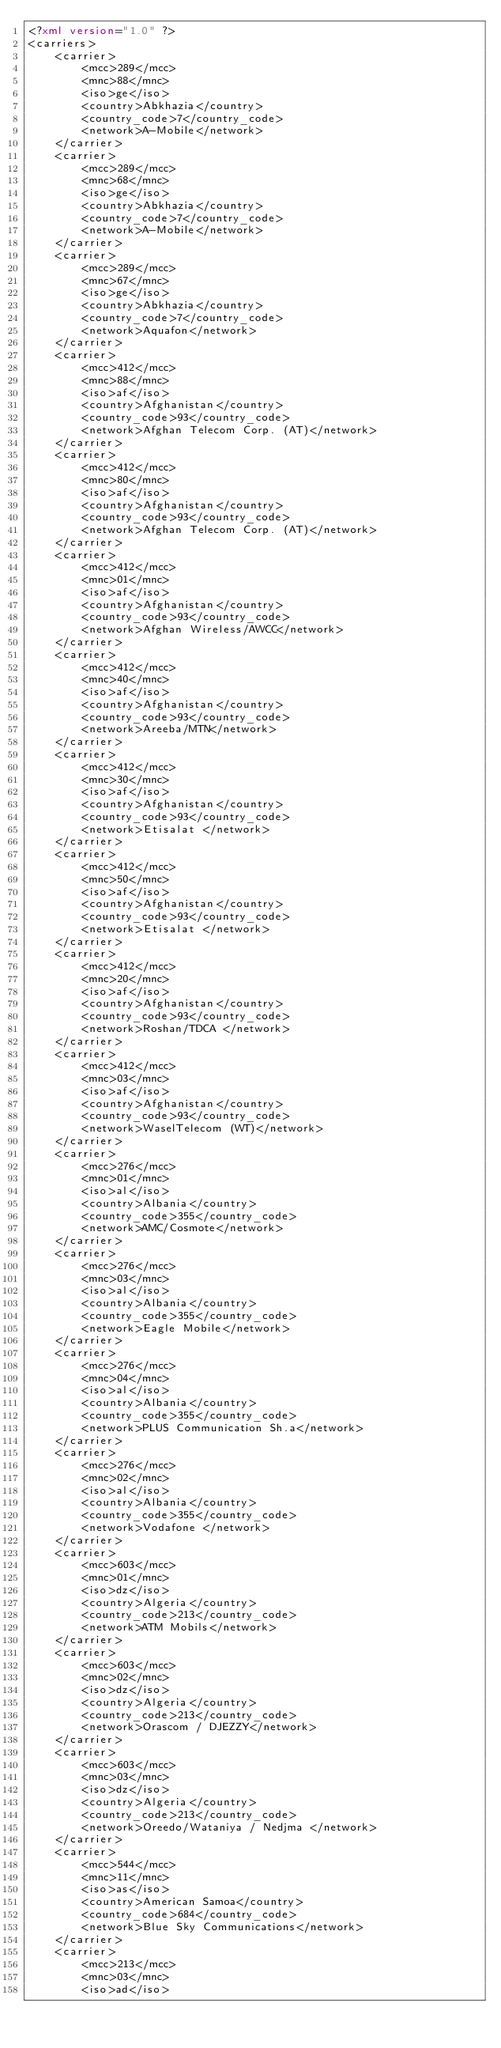Convert code to text. <code><loc_0><loc_0><loc_500><loc_500><_XML_><?xml version="1.0" ?>
<carriers>
    <carrier>
        <mcc>289</mcc>
        <mnc>88</mnc>
        <iso>ge</iso>
        <country>Abkhazia</country>
        <country_code>7</country_code>
        <network>A-Mobile</network>
    </carrier>
    <carrier>
        <mcc>289</mcc>
        <mnc>68</mnc>
        <iso>ge</iso>
        <country>Abkhazia</country>
        <country_code>7</country_code>
        <network>A-Mobile</network>
    </carrier>
    <carrier>
        <mcc>289</mcc>
        <mnc>67</mnc>
        <iso>ge</iso>
        <country>Abkhazia</country>
        <country_code>7</country_code>
        <network>Aquafon</network>
    </carrier>
    <carrier>
        <mcc>412</mcc>
        <mnc>88</mnc>
        <iso>af</iso>
        <country>Afghanistan</country>
        <country_code>93</country_code>
        <network>Afghan Telecom Corp. (AT)</network>
    </carrier>
    <carrier>
        <mcc>412</mcc>
        <mnc>80</mnc>
        <iso>af</iso>
        <country>Afghanistan</country>
        <country_code>93</country_code>
        <network>Afghan Telecom Corp. (AT)</network>
    </carrier>
    <carrier>
        <mcc>412</mcc>
        <mnc>01</mnc>
        <iso>af</iso>
        <country>Afghanistan</country>
        <country_code>93</country_code>
        <network>Afghan Wireless/AWCC</network>
    </carrier>
    <carrier>
        <mcc>412</mcc>
        <mnc>40</mnc>
        <iso>af</iso>
        <country>Afghanistan</country>
        <country_code>93</country_code>
        <network>Areeba/MTN</network>
    </carrier>
    <carrier>
        <mcc>412</mcc>
        <mnc>30</mnc>
        <iso>af</iso>
        <country>Afghanistan</country>
        <country_code>93</country_code>
        <network>Etisalat </network>
    </carrier>
    <carrier>
        <mcc>412</mcc>
        <mnc>50</mnc>
        <iso>af</iso>
        <country>Afghanistan</country>
        <country_code>93</country_code>
        <network>Etisalat </network>
    </carrier>
    <carrier>
        <mcc>412</mcc>
        <mnc>20</mnc>
        <iso>af</iso>
        <country>Afghanistan</country>
        <country_code>93</country_code>
        <network>Roshan/TDCA </network>
    </carrier>
    <carrier>
        <mcc>412</mcc>
        <mnc>03</mnc>
        <iso>af</iso>
        <country>Afghanistan</country>
        <country_code>93</country_code>
        <network>WaselTelecom (WT)</network>
    </carrier>
    <carrier>
        <mcc>276</mcc>
        <mnc>01</mnc>
        <iso>al</iso>
        <country>Albania</country>
        <country_code>355</country_code>
        <network>AMC/Cosmote</network>
    </carrier>
    <carrier>
        <mcc>276</mcc>
        <mnc>03</mnc>
        <iso>al</iso>
        <country>Albania</country>
        <country_code>355</country_code>
        <network>Eagle Mobile</network>
    </carrier>
    <carrier>
        <mcc>276</mcc>
        <mnc>04</mnc>
        <iso>al</iso>
        <country>Albania</country>
        <country_code>355</country_code>
        <network>PLUS Communication Sh.a</network>
    </carrier>
    <carrier>
        <mcc>276</mcc>
        <mnc>02</mnc>
        <iso>al</iso>
        <country>Albania</country>
        <country_code>355</country_code>
        <network>Vodafone </network>
    </carrier>
    <carrier>
        <mcc>603</mcc>
        <mnc>01</mnc>
        <iso>dz</iso>
        <country>Algeria</country>
        <country_code>213</country_code>
        <network>ATM Mobils</network>
    </carrier>
    <carrier>
        <mcc>603</mcc>
        <mnc>02</mnc>
        <iso>dz</iso>
        <country>Algeria</country>
        <country_code>213</country_code>
        <network>Orascom / DJEZZY</network>
    </carrier>
    <carrier>
        <mcc>603</mcc>
        <mnc>03</mnc>
        <iso>dz</iso>
        <country>Algeria</country>
        <country_code>213</country_code>
        <network>Oreedo/Wataniya / Nedjma </network>
    </carrier>
    <carrier>
        <mcc>544</mcc>
        <mnc>11</mnc>
        <iso>as</iso>
        <country>American Samoa</country>
        <country_code>684</country_code>
        <network>Blue Sky Communications</network>
    </carrier>
    <carrier>
        <mcc>213</mcc>
        <mnc>03</mnc>
        <iso>ad</iso></code> 